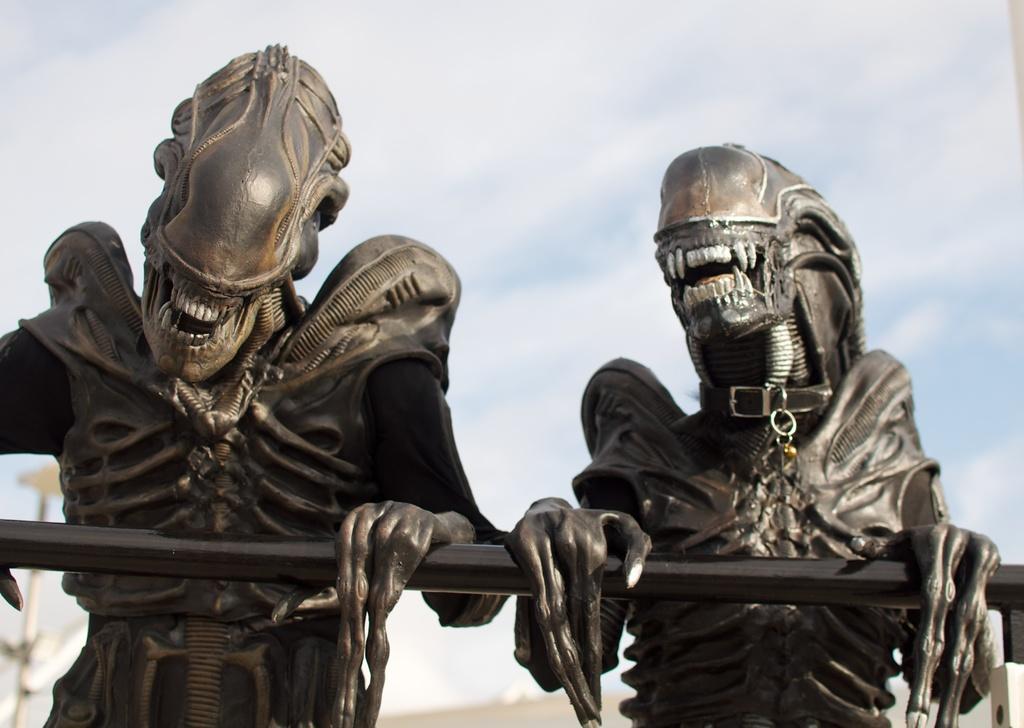Could you give a brief overview of what you see in this image? This is a picture of a two statues holding a black rod in front of them. 